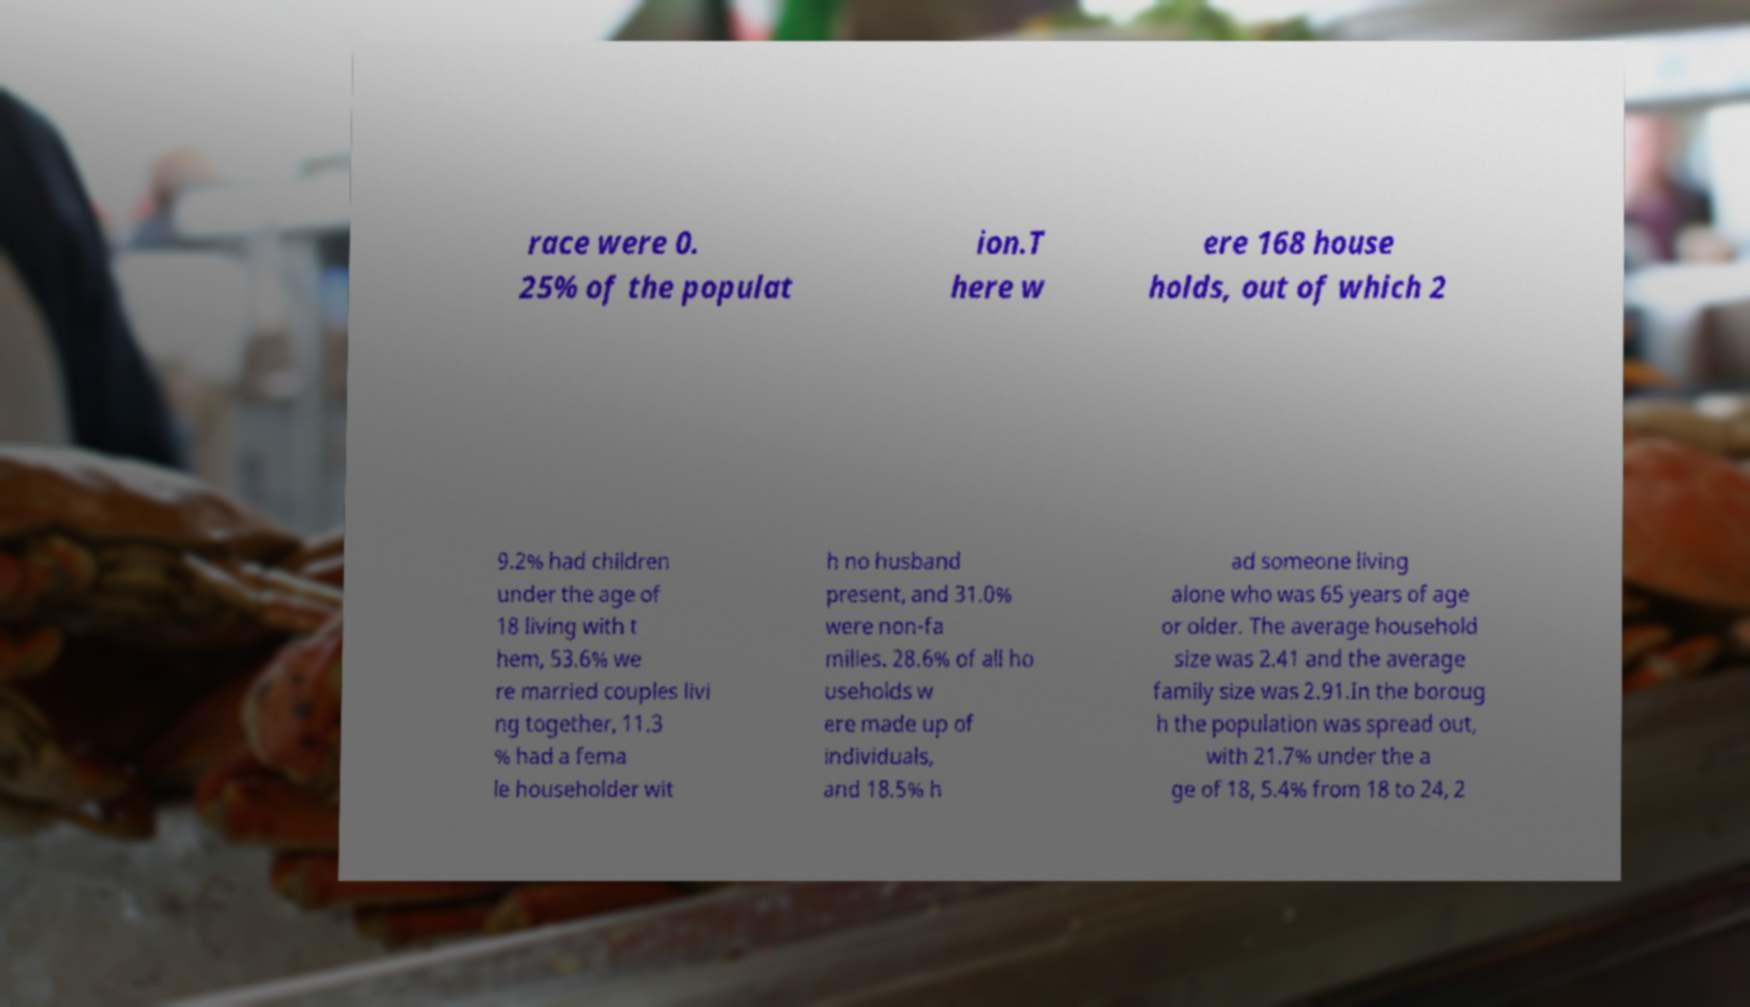I need the written content from this picture converted into text. Can you do that? race were 0. 25% of the populat ion.T here w ere 168 house holds, out of which 2 9.2% had children under the age of 18 living with t hem, 53.6% we re married couples livi ng together, 11.3 % had a fema le householder wit h no husband present, and 31.0% were non-fa milies. 28.6% of all ho useholds w ere made up of individuals, and 18.5% h ad someone living alone who was 65 years of age or older. The average household size was 2.41 and the average family size was 2.91.In the boroug h the population was spread out, with 21.7% under the a ge of 18, 5.4% from 18 to 24, 2 